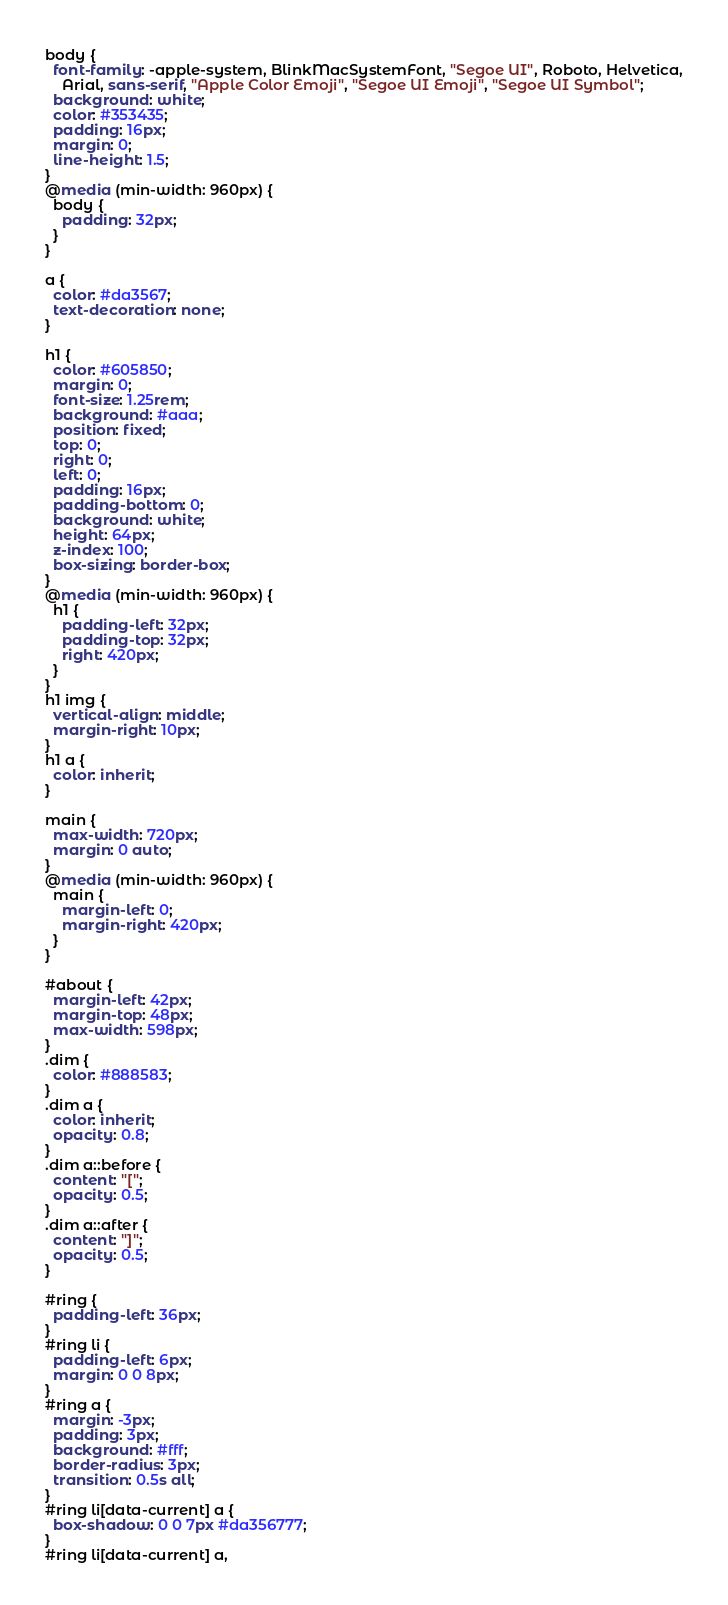<code> <loc_0><loc_0><loc_500><loc_500><_CSS_>body {
  font-family: -apple-system, BlinkMacSystemFont, "Segoe UI", Roboto, Helvetica,
    Arial, sans-serif, "Apple Color Emoji", "Segoe UI Emoji", "Segoe UI Symbol";
  background: white;
  color: #353435;
  padding: 16px;
  margin: 0;
  line-height: 1.5;
}
@media (min-width: 960px) {
  body {
    padding: 32px;
  }
}

a {
  color: #da3567;
  text-decoration: none;
}

h1 {
  color: #605850;
  margin: 0;
  font-size: 1.25rem;
  background: #aaa;
  position: fixed;
  top: 0;
  right: 0;
  left: 0;
  padding: 16px;
  padding-bottom: 0;
  background: white;
  height: 64px;
  z-index: 100;
  box-sizing: border-box;
}
@media (min-width: 960px) {
  h1 {
    padding-left: 32px;
    padding-top: 32px;
    right: 420px;
  }
}
h1 img {
  vertical-align: middle;
  margin-right: 10px;
}
h1 a {
  color: inherit;
}

main {
  max-width: 720px;
  margin: 0 auto;
}
@media (min-width: 960px) {
  main {
    margin-left: 0;
    margin-right: 420px;
  }
}

#about {
  margin-left: 42px;
  margin-top: 48px;
  max-width: 598px;
}
.dim {
  color: #888583;
}
.dim a {
  color: inherit;
  opacity: 0.8;
}
.dim a::before {
  content: "[";
  opacity: 0.5;
}
.dim a::after {
  content: "]";
  opacity: 0.5;
}

#ring {
  padding-left: 36px;
}
#ring li {
  padding-left: 6px;
  margin: 0 0 8px;
}
#ring a {
  margin: -3px;
  padding: 3px;
  background: #fff;
  border-radius: 3px;
  transition: 0.5s all;
}
#ring li[data-current] a {
  box-shadow: 0 0 7px #da356777;
}
#ring li[data-current] a,</code> 